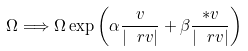Convert formula to latex. <formula><loc_0><loc_0><loc_500><loc_500>\Omega \Longrightarrow \Omega \exp \left ( \alpha \frac { v } { | \ r v | } + \beta \frac { * v } { | \ r v | } \right )</formula> 